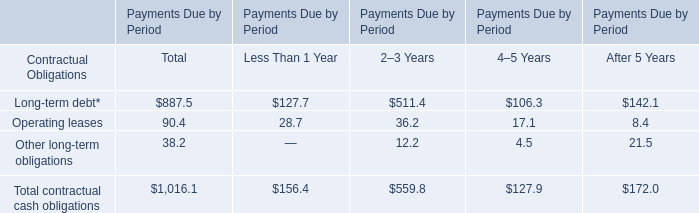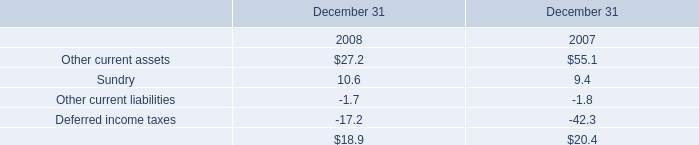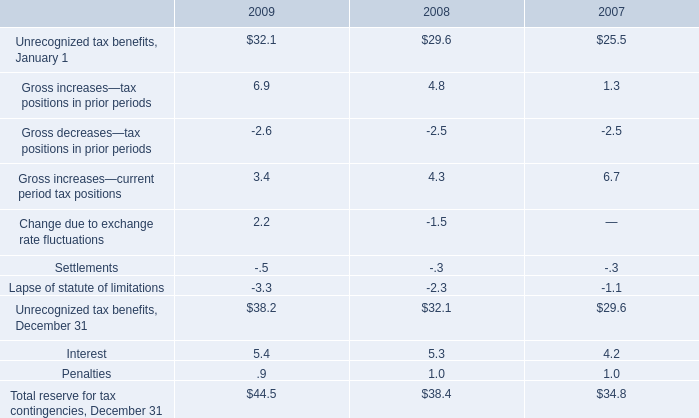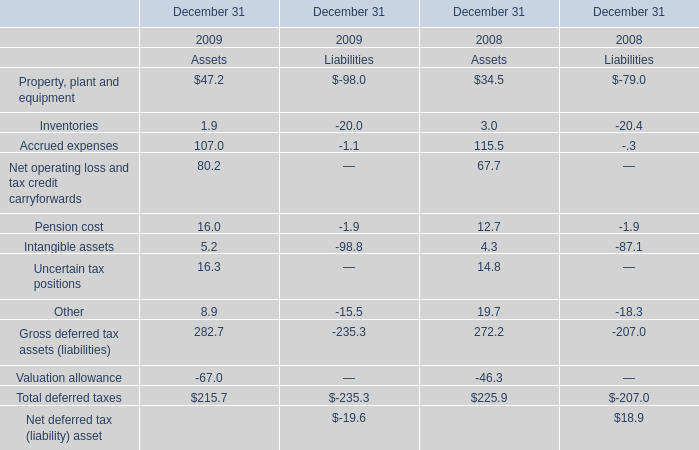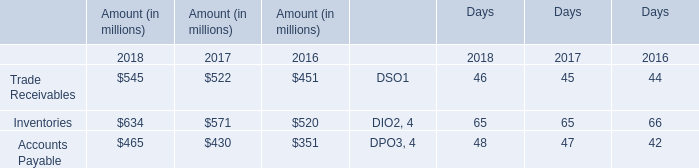What is the sum of the Pension cost in the years where Uncertain tax positions greater than 0? 
Computations: (((16.0 - 1.9) + 12.7) - 1.9)
Answer: 24.9. 